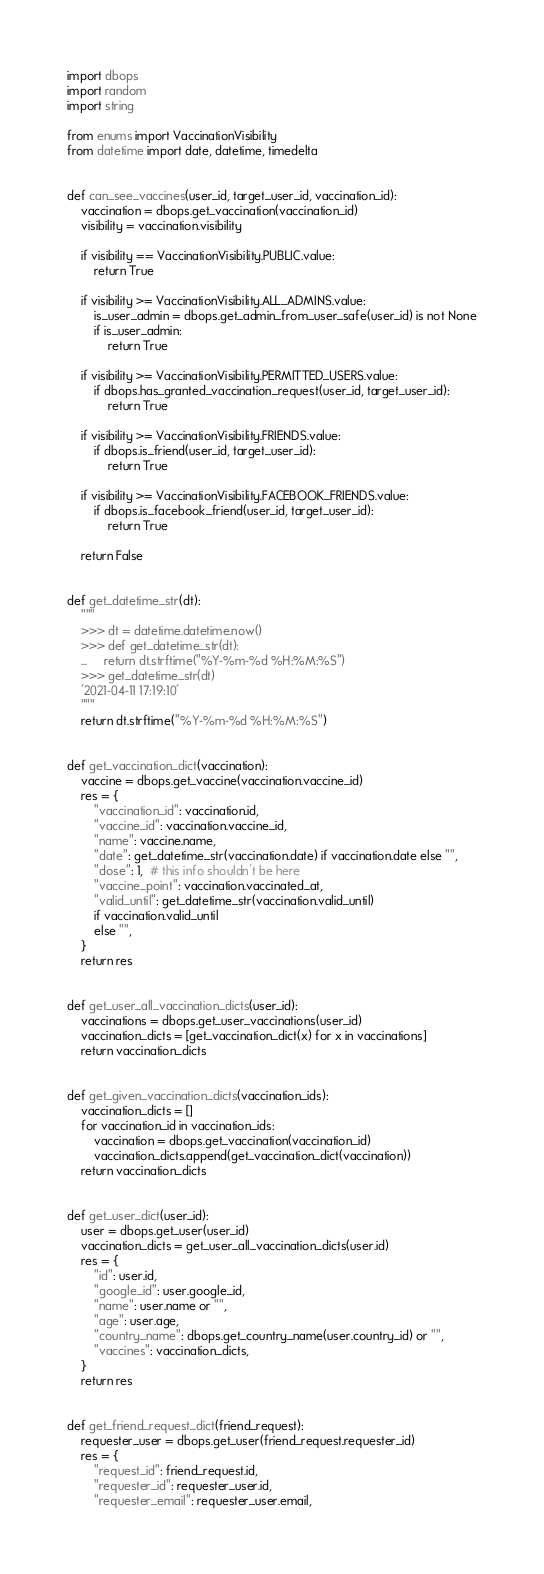<code> <loc_0><loc_0><loc_500><loc_500><_Python_>import dbops
import random
import string

from enums import VaccinationVisibility
from datetime import date, datetime, timedelta


def can_see_vaccines(user_id, target_user_id, vaccination_id):
    vaccination = dbops.get_vaccination(vaccination_id)
    visibility = vaccination.visibility

    if visibility == VaccinationVisibility.PUBLIC.value:
        return True

    if visibility >= VaccinationVisibility.ALL_ADMINS.value:
        is_user_admin = dbops.get_admin_from_user_safe(user_id) is not None
        if is_user_admin:
            return True

    if visibility >= VaccinationVisibility.PERMITTED_USERS.value:
        if dbops.has_granted_vaccination_request(user_id, target_user_id):
            return True

    if visibility >= VaccinationVisibility.FRIENDS.value:
        if dbops.is_friend(user_id, target_user_id):
            return True

    if visibility >= VaccinationVisibility.FACEBOOK_FRIENDS.value:
        if dbops.is_facebook_friend(user_id, target_user_id):
            return True

    return False


def get_datetime_str(dt):
    """
    >>> dt = datetime.datetime.now()
    >>> def get_datetime_str(dt):
    ...     return dt.strftime("%Y-%m-%d %H:%M:%S")
    >>> get_datetime_str(dt)
    '2021-04-11 17:19:10'
    """
    return dt.strftime("%Y-%m-%d %H:%M:%S")


def get_vaccination_dict(vaccination):
    vaccine = dbops.get_vaccine(vaccination.vaccine_id)
    res = {
        "vaccination_id": vaccination.id,
        "vaccine_id": vaccination.vaccine_id,
        "name": vaccine.name,
        "date": get_datetime_str(vaccination.date) if vaccination.date else "",
        "dose": 1,  # this info shouldn't be here
        "vaccine_point": vaccination.vaccinated_at,
        "valid_until": get_datetime_str(vaccination.valid_until)
        if vaccination.valid_until
        else "",
    }
    return res


def get_user_all_vaccination_dicts(user_id):
    vaccinations = dbops.get_user_vaccinations(user_id)
    vaccination_dicts = [get_vaccination_dict(x) for x in vaccinations]
    return vaccination_dicts


def get_given_vaccination_dicts(vaccination_ids):
    vaccination_dicts = []
    for vaccination_id in vaccination_ids:
        vaccination = dbops.get_vaccination(vaccination_id)
        vaccination_dicts.append(get_vaccination_dict(vaccination))
    return vaccination_dicts


def get_user_dict(user_id):
    user = dbops.get_user(user_id)
    vaccination_dicts = get_user_all_vaccination_dicts(user.id)
    res = {
        "id": user.id,
        "google_id": user.google_id,
        "name": user.name or "",
        "age": user.age,
        "country_name": dbops.get_country_name(user.country_id) or "",
        "vaccines": vaccination_dicts,
    }
    return res


def get_friend_request_dict(friend_request):
    requester_user = dbops.get_user(friend_request.requester_id)
    res = {
        "request_id": friend_request.id,
        "requester_id": requester_user.id,
        "requester_email": requester_user.email,</code> 